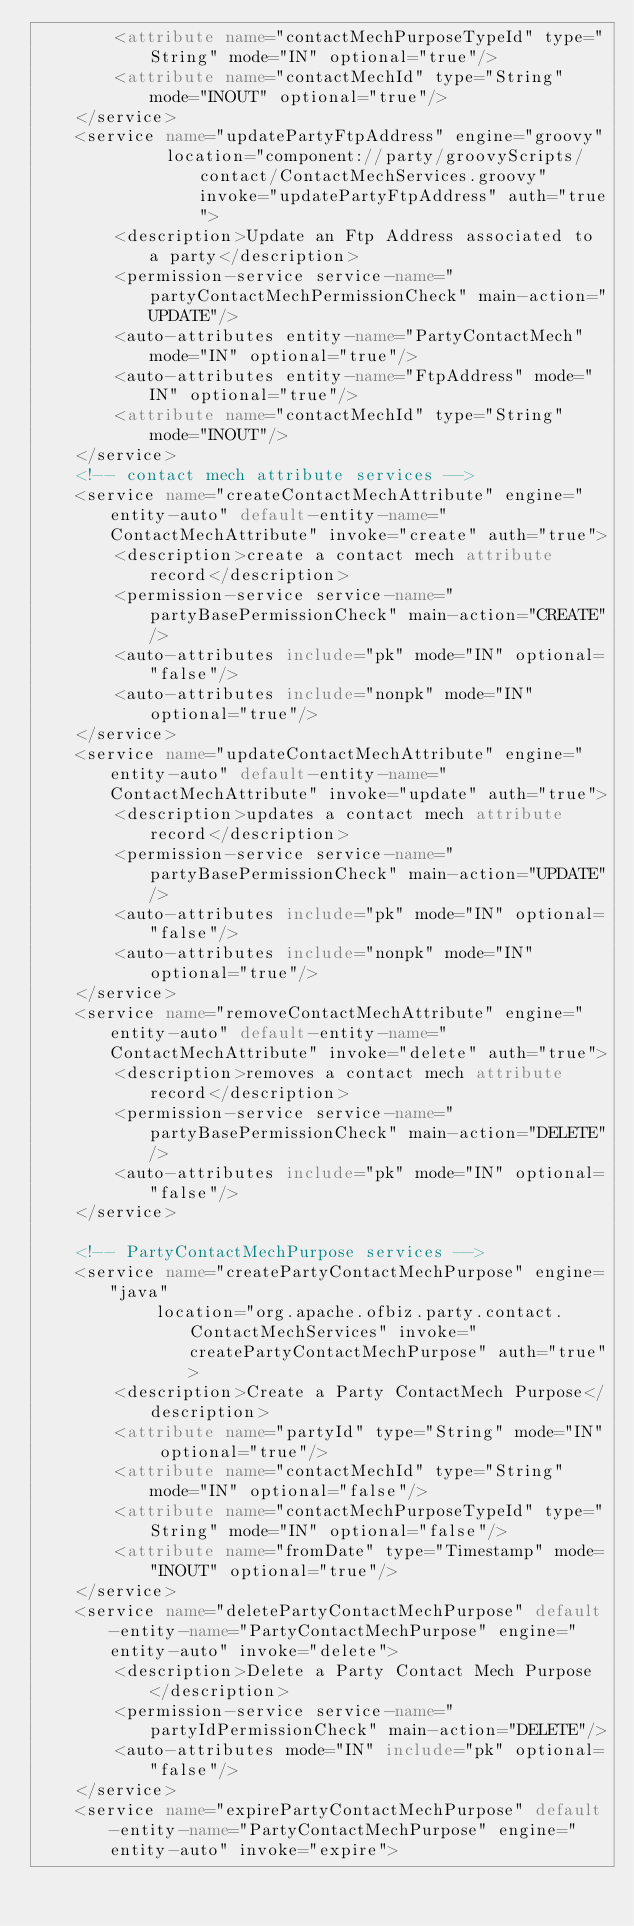Convert code to text. <code><loc_0><loc_0><loc_500><loc_500><_XML_>        <attribute name="contactMechPurposeTypeId" type="String" mode="IN" optional="true"/>
        <attribute name="contactMechId" type="String" mode="INOUT" optional="true"/>
    </service>
    <service name="updatePartyFtpAddress" engine="groovy"
             location="component://party/groovyScripts/contact/ContactMechServices.groovy" invoke="updatePartyFtpAddress" auth="true">
        <description>Update an Ftp Address associated to a party</description>
        <permission-service service-name="partyContactMechPermissionCheck" main-action="UPDATE"/>
        <auto-attributes entity-name="PartyContactMech" mode="IN" optional="true"/>
        <auto-attributes entity-name="FtpAddress" mode="IN" optional="true"/>
        <attribute name="contactMechId" type="String" mode="INOUT"/>
    </service>
    <!-- contact mech attribute services -->
    <service name="createContactMechAttribute" engine="entity-auto" default-entity-name="ContactMechAttribute" invoke="create" auth="true">
        <description>create a contact mech attribute record</description>
        <permission-service service-name="partyBasePermissionCheck" main-action="CREATE"/>
        <auto-attributes include="pk" mode="IN" optional="false"/>
        <auto-attributes include="nonpk" mode="IN" optional="true"/>
    </service>
    <service name="updateContactMechAttribute" engine="entity-auto" default-entity-name="ContactMechAttribute" invoke="update" auth="true">
        <description>updates a contact mech attribute record</description>
        <permission-service service-name="partyBasePermissionCheck" main-action="UPDATE"/>
        <auto-attributes include="pk" mode="IN" optional="false"/>
        <auto-attributes include="nonpk" mode="IN" optional="true"/>
    </service>
    <service name="removeContactMechAttribute" engine="entity-auto" default-entity-name="ContactMechAttribute" invoke="delete" auth="true">
        <description>removes a contact mech attribute record</description>
        <permission-service service-name="partyBasePermissionCheck" main-action="DELETE"/>
        <auto-attributes include="pk" mode="IN" optional="false"/>
    </service>

    <!-- PartyContactMechPurpose services -->
    <service name="createPartyContactMechPurpose" engine="java"
            location="org.apache.ofbiz.party.contact.ContactMechServices" invoke="createPartyContactMechPurpose" auth="true">
        <description>Create a Party ContactMech Purpose</description>
        <attribute name="partyId" type="String" mode="IN" optional="true"/>
        <attribute name="contactMechId" type="String" mode="IN" optional="false"/>
        <attribute name="contactMechPurposeTypeId" type="String" mode="IN" optional="false"/>
        <attribute name="fromDate" type="Timestamp" mode="INOUT" optional="true"/>
    </service>
    <service name="deletePartyContactMechPurpose" default-entity-name="PartyContactMechPurpose" engine="entity-auto" invoke="delete">
        <description>Delete a Party Contact Mech Purpose</description>
        <permission-service service-name="partyIdPermissionCheck" main-action="DELETE"/>
        <auto-attributes mode="IN" include="pk" optional="false"/>
    </service>
    <service name="expirePartyContactMechPurpose" default-entity-name="PartyContactMechPurpose" engine="entity-auto" invoke="expire"></code> 